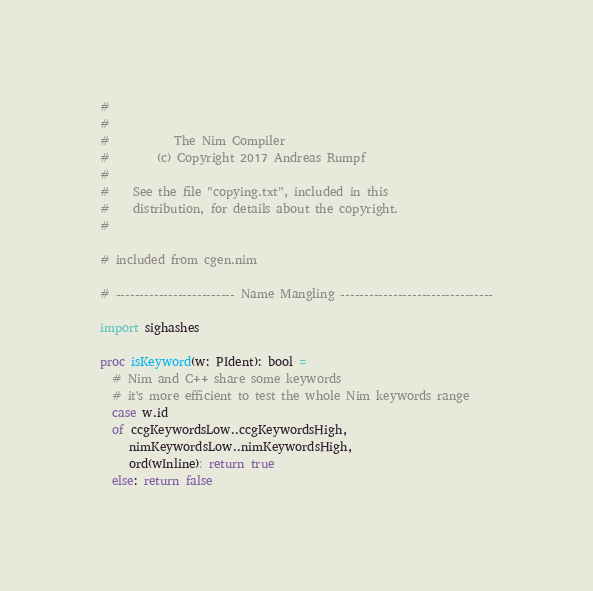<code> <loc_0><loc_0><loc_500><loc_500><_Nim_>#
#
#           The Nim Compiler
#        (c) Copyright 2017 Andreas Rumpf
#
#    See the file "copying.txt", included in this
#    distribution, for details about the copyright.
#

# included from cgen.nim

# ------------------------- Name Mangling --------------------------------

import sighashes

proc isKeyword(w: PIdent): bool =
  # Nim and C++ share some keywords
  # it's more efficient to test the whole Nim keywords range
  case w.id
  of ccgKeywordsLow..ccgKeywordsHigh,
     nimKeywordsLow..nimKeywordsHigh,
     ord(wInline): return true
  else: return false
</code> 